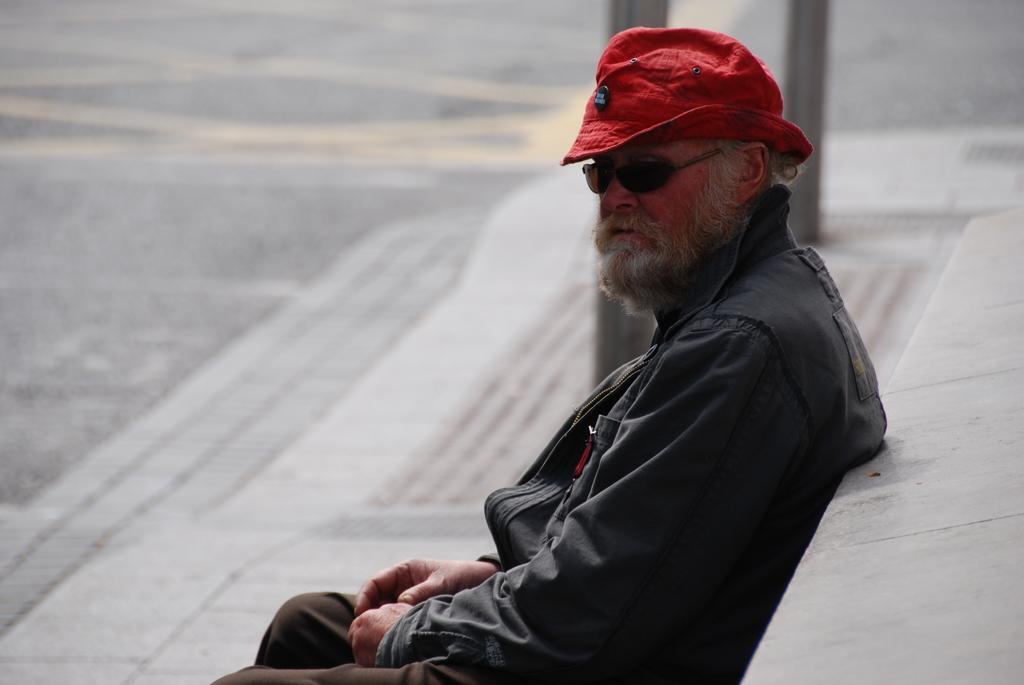Can you describe this image briefly? In this picture I can see a man wearing a coat, a cap. At the top it looks like the road. 